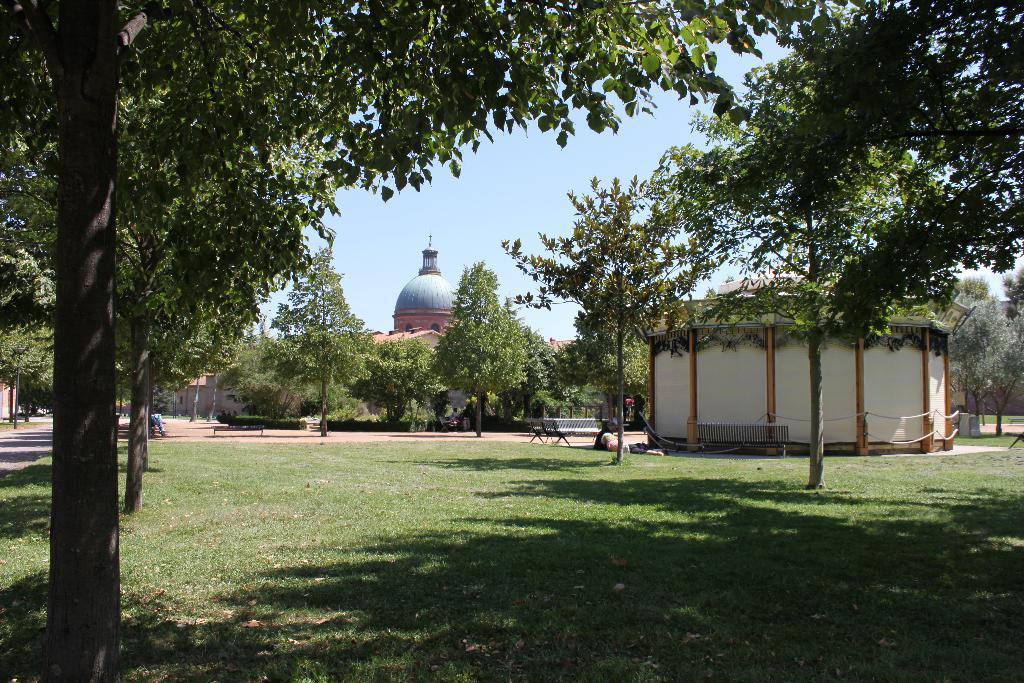Could you give a brief overview of what you see in this image? In this picture there are buildings and trees and there are benches. At the back there might be two persons. At the bottom there is grass and there is ground and there is a pavement. 